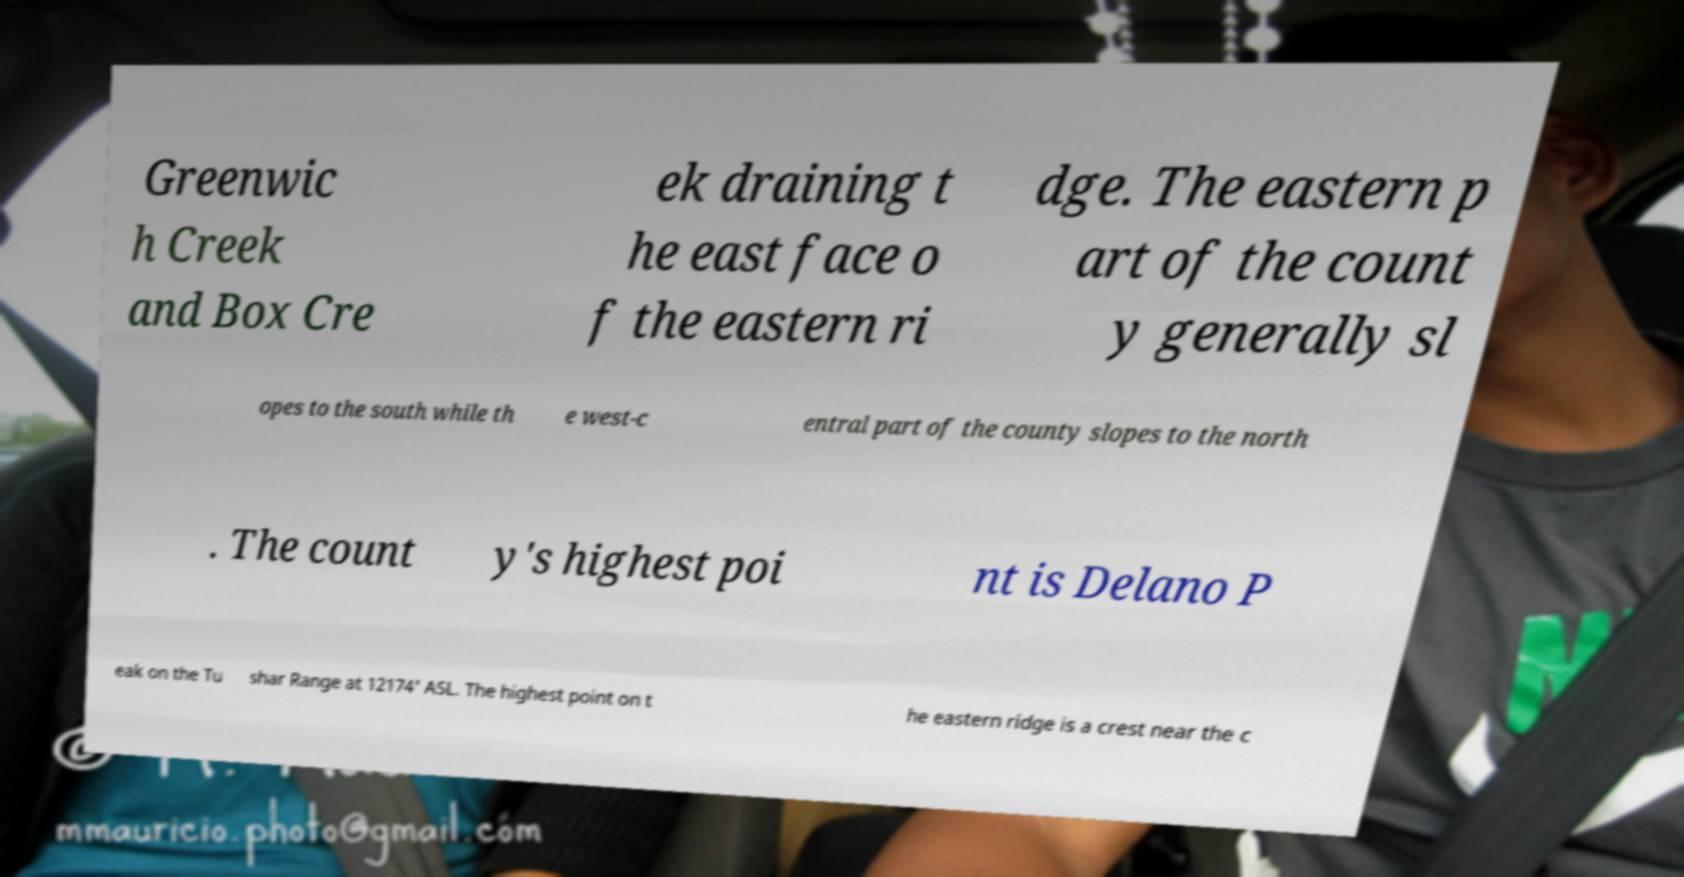Please read and relay the text visible in this image. What does it say? Greenwic h Creek and Box Cre ek draining t he east face o f the eastern ri dge. The eastern p art of the count y generally sl opes to the south while th e west-c entral part of the county slopes to the north . The count y's highest poi nt is Delano P eak on the Tu shar Range at 12174' ASL. The highest point on t he eastern ridge is a crest near the c 